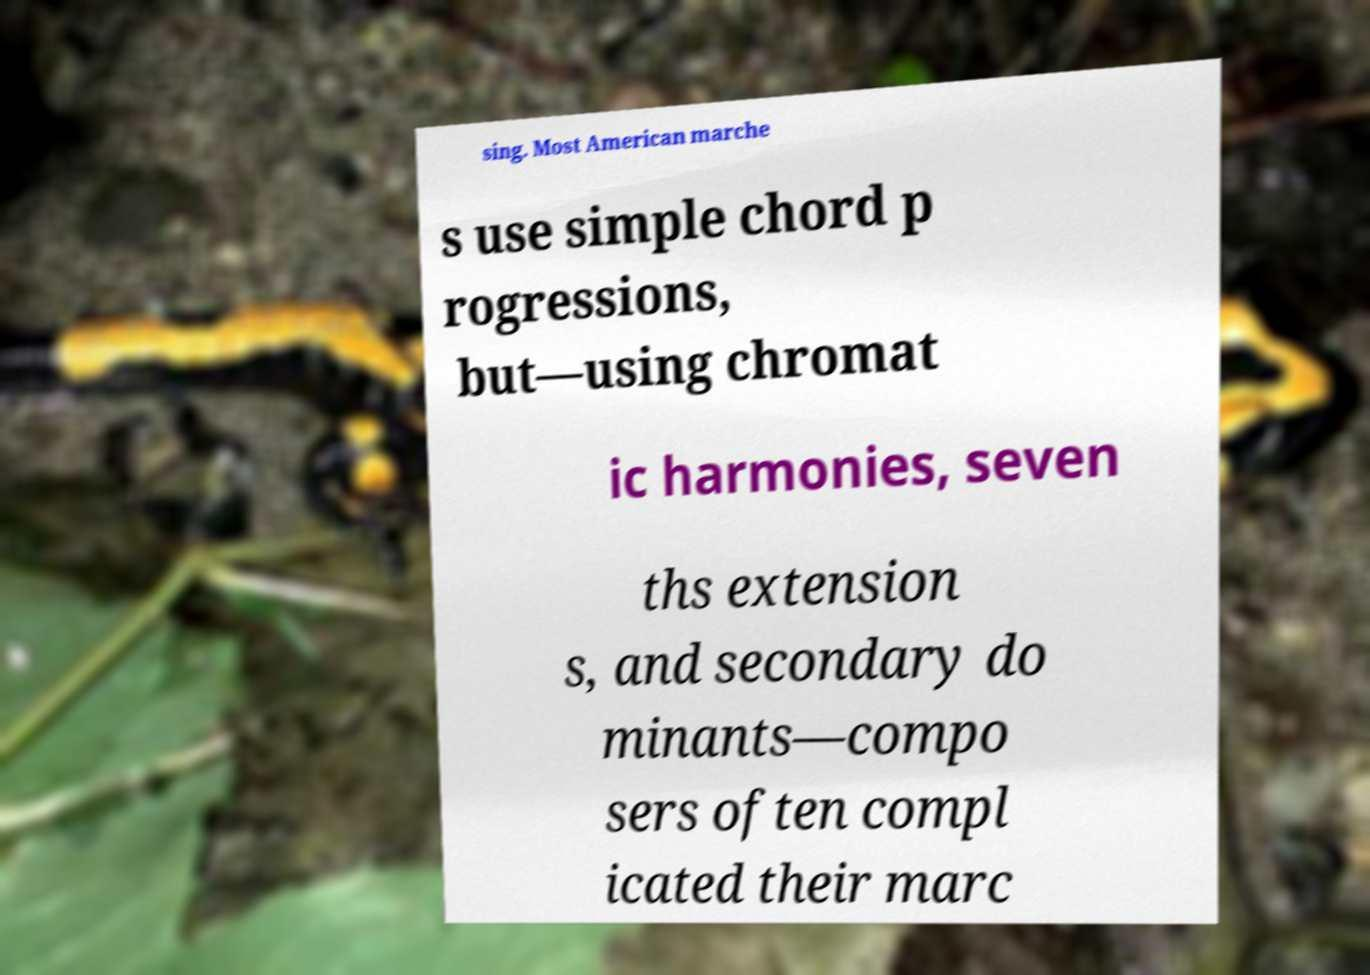What messages or text are displayed in this image? I need them in a readable, typed format. sing. Most American marche s use simple chord p rogressions, but—using chromat ic harmonies, seven ths extension s, and secondary do minants—compo sers often compl icated their marc 